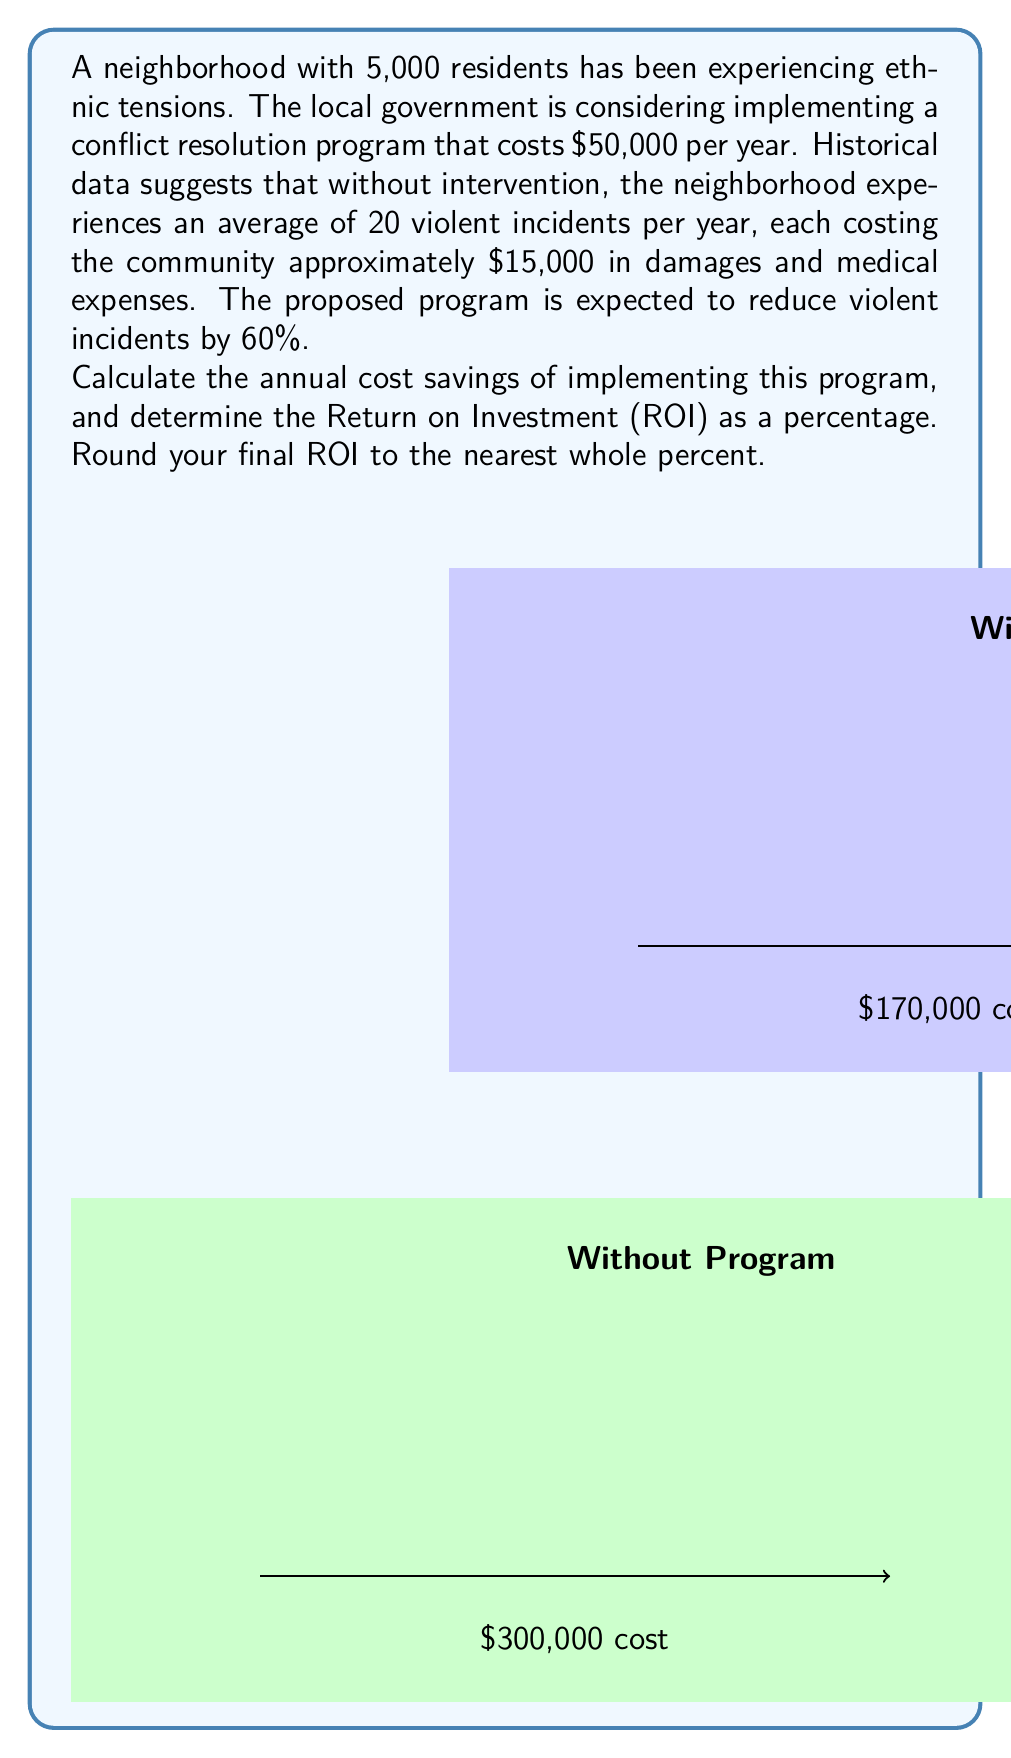Can you answer this question? Let's approach this problem step-by-step:

1) First, calculate the current annual cost of violent incidents:
   $$20 \text{ incidents} \times \$15,000 = \$300,000$$

2) Calculate the expected number of incidents after implementing the program:
   $$20 \text{ incidents} \times (1 - 0.60) = 8 \text{ incidents}$$

3) Calculate the new annual cost of violent incidents:
   $$8 \text{ incidents} \times \$15,000 = \$120,000$$

4) Calculate the total cost with the program:
   $$\$120,000 \text{ (incident costs)} + \$50,000 \text{ (program cost)} = \$170,000$$

5) Calculate the annual cost savings:
   $$\$300,000 \text{ (without program)} - \$170,000 \text{ (with program)} = \$130,000$$

6) Calculate the Return on Investment (ROI):
   ROI is typically calculated as: $\frac{\text{Gain from Investment} - \text{Cost of Investment}}{\text{Cost of Investment}} \times 100\%$

   $$\text{ROI} = \frac{\$130,000 - \$50,000}{\$50,000} \times 100\% = 160\%$$

Therefore, the annual cost savings are $130,000, and the ROI is 160%.
Answer: $130,000 annual savings; 160% ROI 